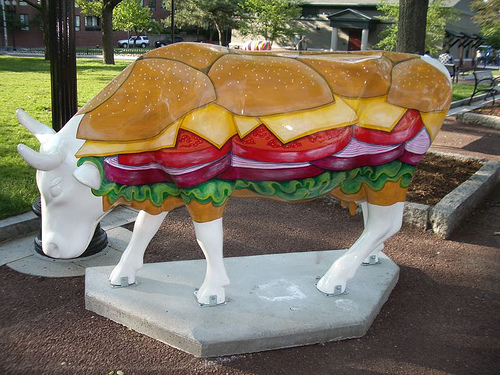<image>
Can you confirm if the cow is on the grass? No. The cow is not positioned on the grass. They may be near each other, but the cow is not supported by or resting on top of the grass. 